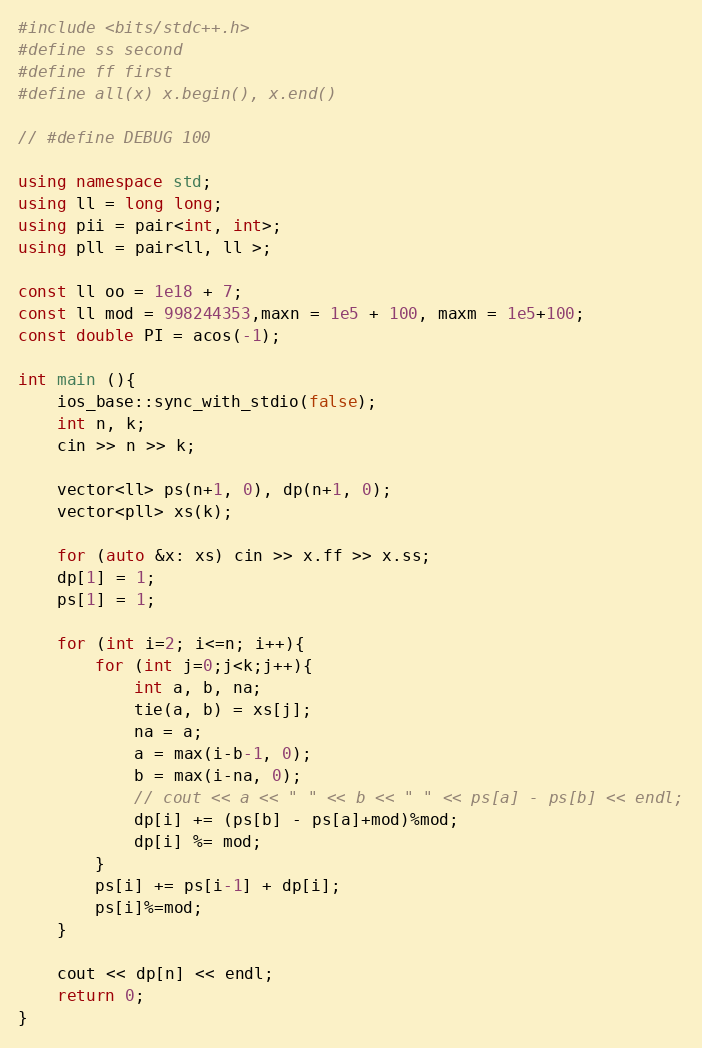Convert code to text. <code><loc_0><loc_0><loc_500><loc_500><_C++_>#include <bits/stdc++.h>
#define ss second
#define ff first
#define all(x) x.begin(), x.end()
 
// #define DEBUG 100
 
using namespace std;
using ll = long long;
using pii = pair<int, int>;
using pll = pair<ll, ll >;
 
const ll oo = 1e18 + 7;
const ll mod = 998244353,maxn = 1e5 + 100, maxm = 1e5+100;
const double PI = acos(-1);

int main (){
    ios_base::sync_with_stdio(false);
    int n, k;
    cin >> n >> k;

    vector<ll> ps(n+1, 0), dp(n+1, 0);
    vector<pll> xs(k);

    for (auto &x: xs) cin >> x.ff >> x.ss;
    dp[1] = 1;
    ps[1] = 1;

    for (int i=2; i<=n; i++){
        for (int j=0;j<k;j++){
            int a, b, na;
            tie(a, b) = xs[j];
            na = a;
            a = max(i-b-1, 0);
            b = max(i-na, 0);
            // cout << a << " " << b << " " << ps[a] - ps[b] << endl;
            dp[i] += (ps[b] - ps[a]+mod)%mod;
            dp[i] %= mod;
        }
        ps[i] += ps[i-1] + dp[i];
        ps[i]%=mod;
    }

    cout << dp[n] << endl;
    return 0;
}</code> 